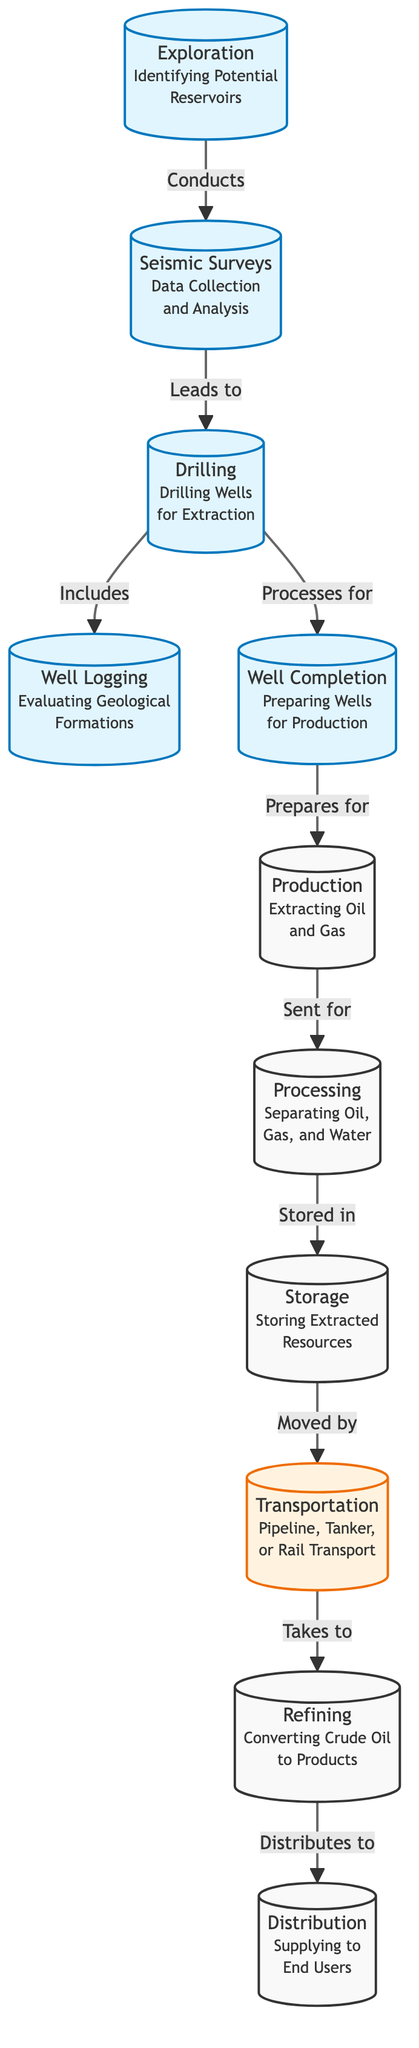What is the first step in the petroleum production process? The diagram indicates that the first step is "Exploration," which involves identifying potential reservoirs.
Answer: Exploration What type of surveys lead to drilling? The diagram states that "Seismic Surveys" lead to drilling, highlighting their role in data collection and analysis.
Answer: Seismic Surveys How many main processes are shown before oil and gas production? There are five main processes shown before production: Exploration, Seismic Surveys, Drilling, Well Logging, and Well Completion. Counting these gives a total of five.
Answer: 5 What happens immediately after the production of oil and gas? The diagram indicates that after production, the oil and gas are sent for "Processing" to separate them from water.
Answer: Processing Which step involves evaluating geological formations? According to the diagram, "Well Logging" is the step that involves evaluating geological formations.
Answer: Well Logging What is done to the extracted resources after processing? The diagram shows that after processing, the extracted resources are stored in "Storage".
Answer: Storage Explain what leads from transportation to refining. The diagram indicates that "Transportation" moves the resources to "Refining", converting crude oil to products, demonstrating a direct flow from one to the other.
Answer: Refining What is the relationship between refining and distribution? From the diagram, refining distributes to distribution, indicating that products from refining are supplied to end users.
Answer: Distributes to How are the extracted resources moved after storage? The diagram specifies that the extracted resources are moved by "Transportation", which could include pipelines, tankers, or rail transport.
Answer: Moved by What type of transport can be seen in the transportation node? The diagram lists "Pipeline, Tanker, or Rail Transport" as the types of transportation available for moving resources.
Answer: Pipeline, Tanker, or Rail Transport 